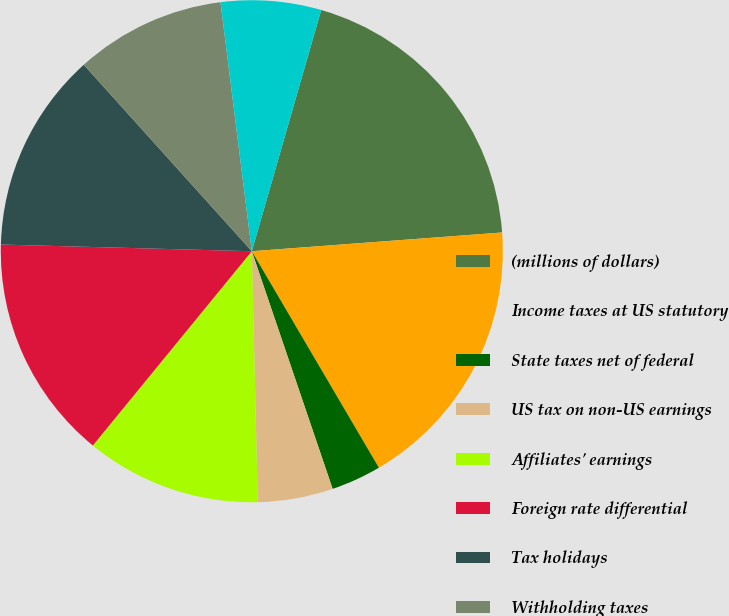Convert chart. <chart><loc_0><loc_0><loc_500><loc_500><pie_chart><fcel>(millions of dollars)<fcel>Income taxes at US statutory<fcel>State taxes net of federal<fcel>US tax on non-US earnings<fcel>Affiliates' earnings<fcel>Foreign rate differential<fcel>Tax holidays<fcel>Withholding taxes<fcel>Tax credits<fcel>Reserve adjustments<nl><fcel>19.35%<fcel>17.74%<fcel>3.23%<fcel>4.84%<fcel>11.29%<fcel>14.51%<fcel>12.9%<fcel>9.68%<fcel>6.45%<fcel>0.0%<nl></chart> 